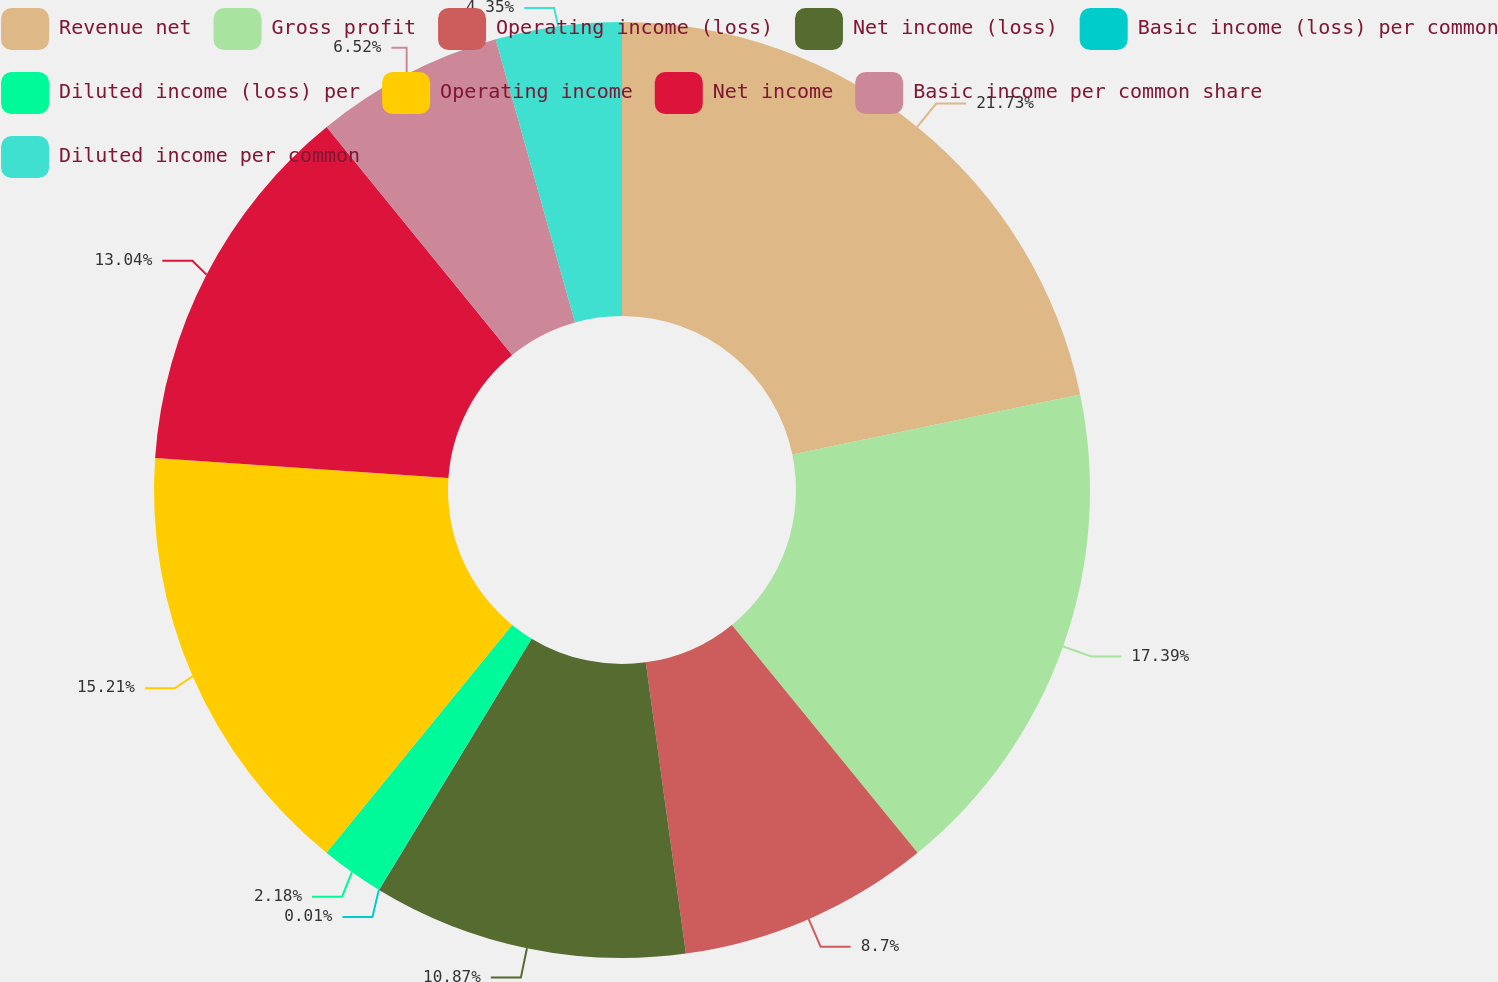Convert chart to OTSL. <chart><loc_0><loc_0><loc_500><loc_500><pie_chart><fcel>Revenue net<fcel>Gross profit<fcel>Operating income (loss)<fcel>Net income (loss)<fcel>Basic income (loss) per common<fcel>Diluted income (loss) per<fcel>Operating income<fcel>Net income<fcel>Basic income per common share<fcel>Diluted income per common<nl><fcel>21.73%<fcel>17.39%<fcel>8.7%<fcel>10.87%<fcel>0.01%<fcel>2.18%<fcel>15.21%<fcel>13.04%<fcel>6.52%<fcel>4.35%<nl></chart> 